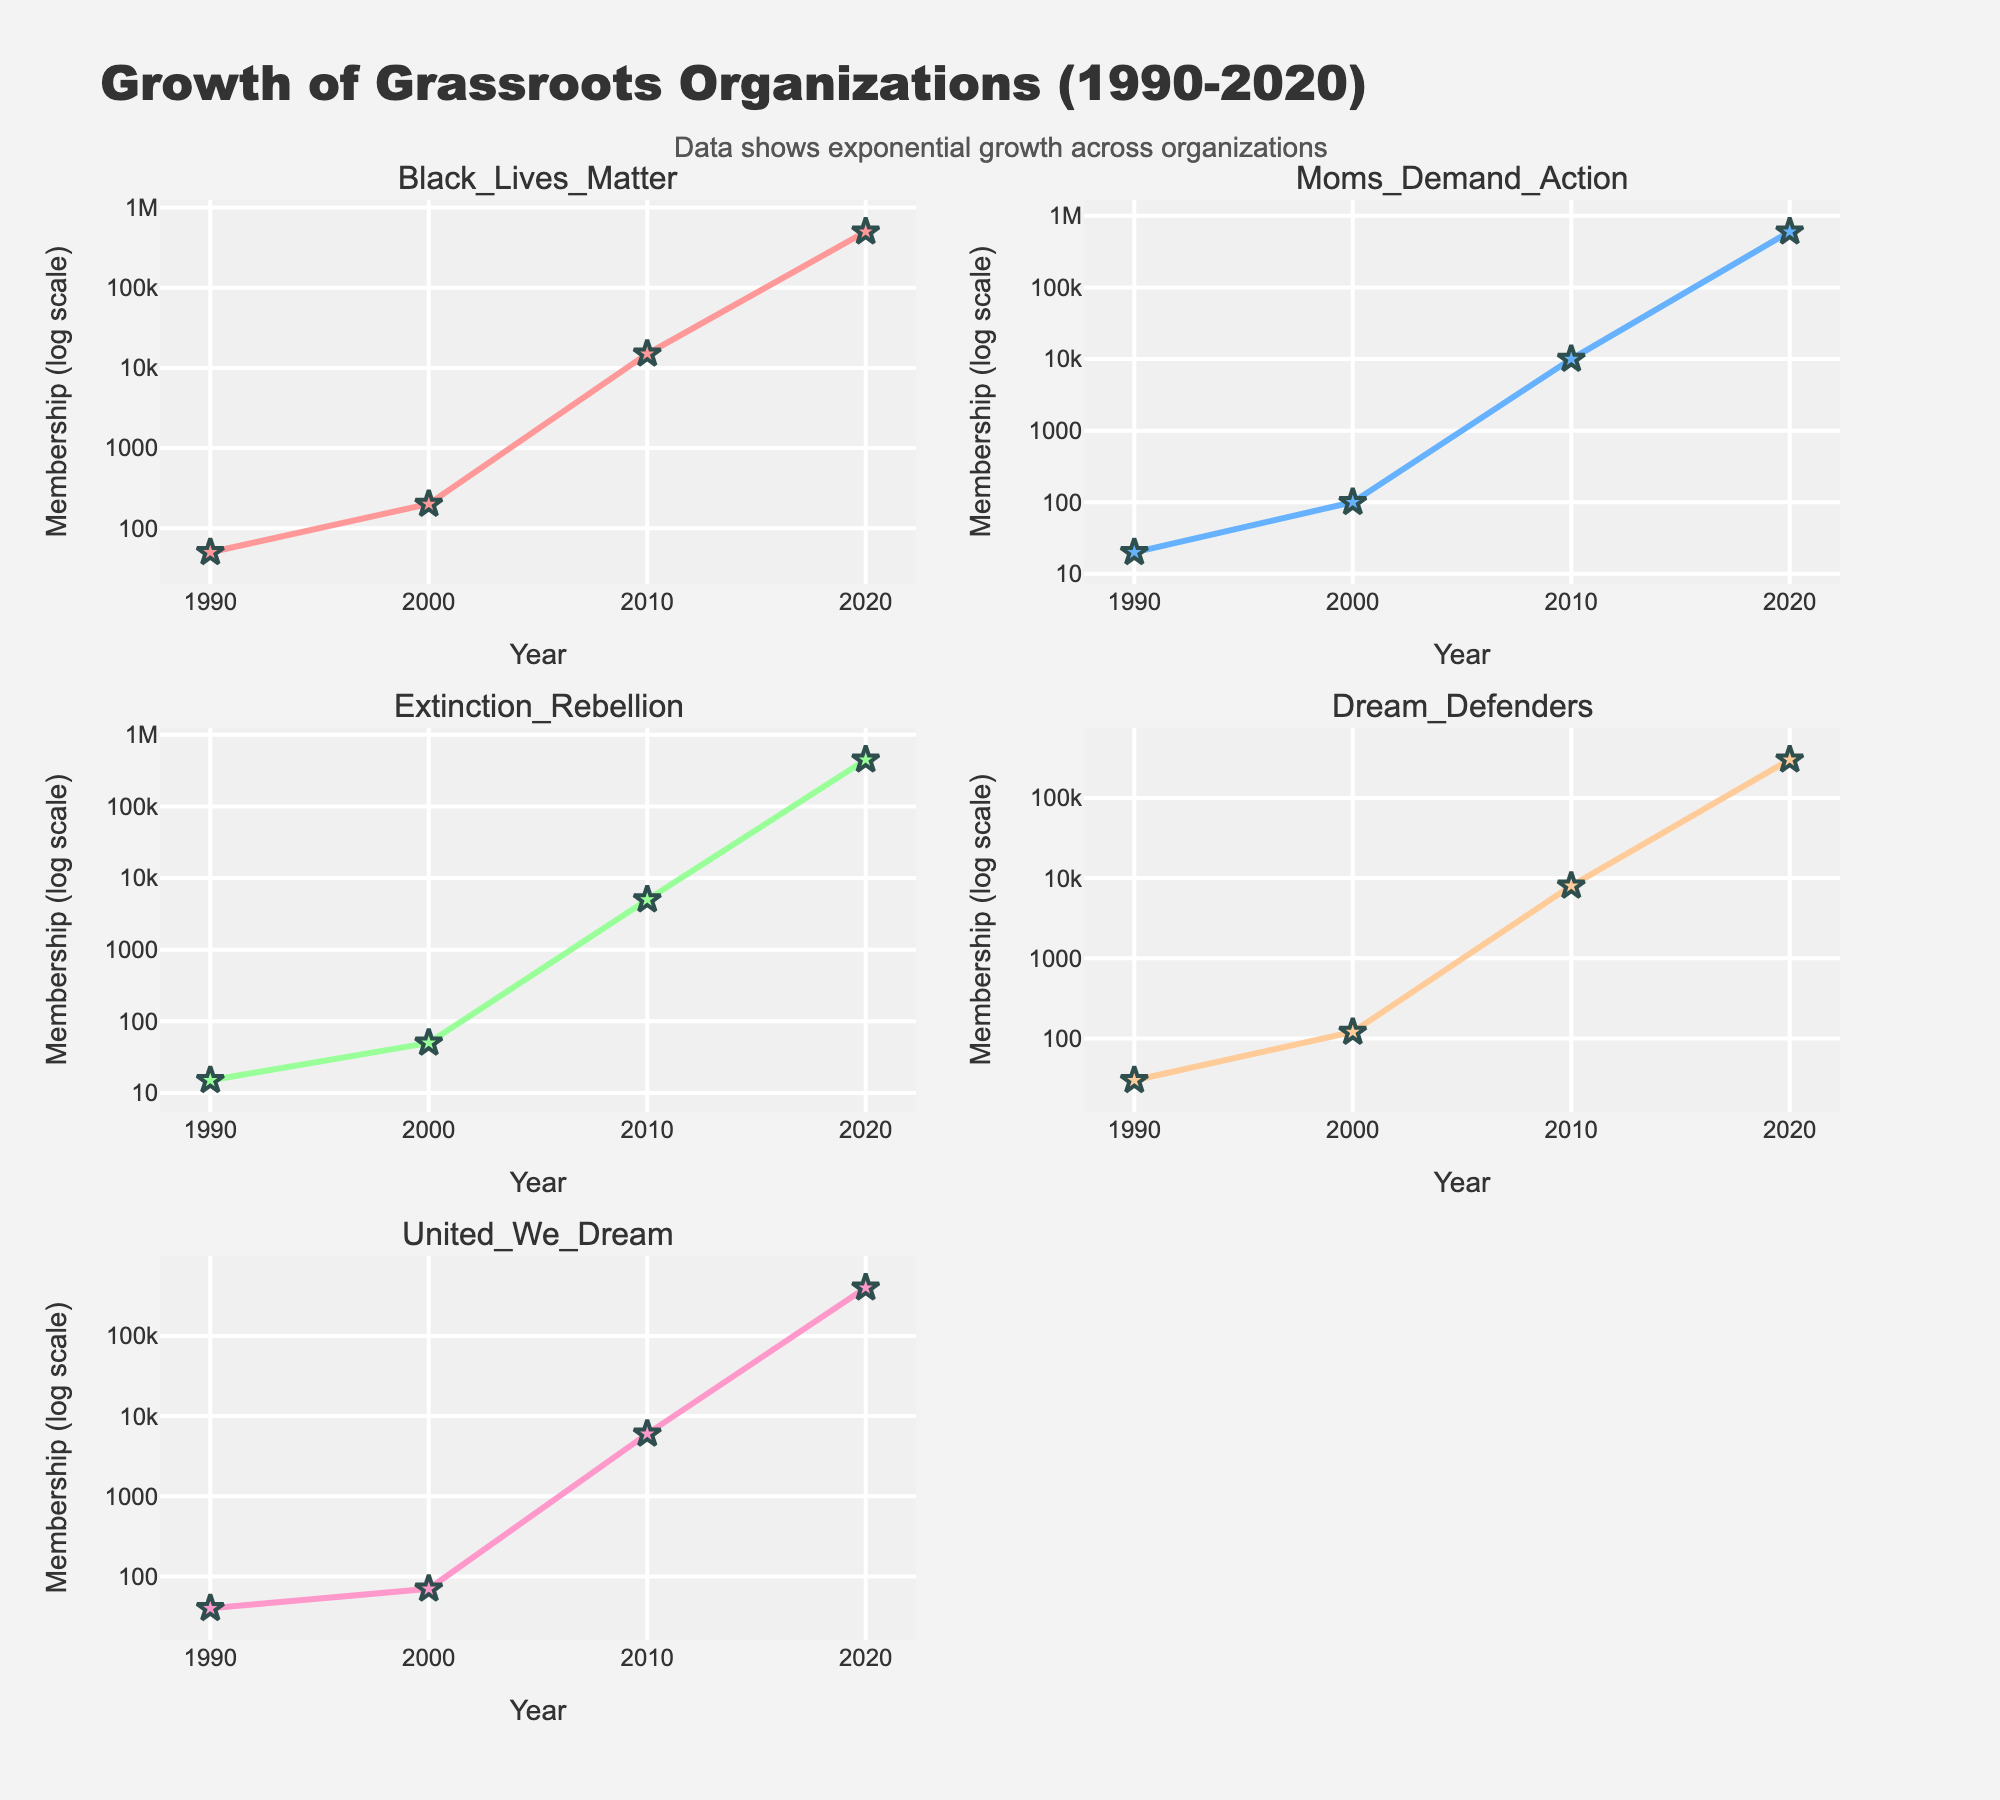What is the overall trend in the membership size of the "Black Lives Matter" organization from 1990 to 2020? To identify the trend, look at the plot for "Black Lives Matter". The plot shows an increasing trend, particularly noticeable between 2000 to 2020, where the membership size increases exponentially.
Answer: Significant growth Which organization had the highest membership size in 2020? To find this, compare the 2020 data points across all subplots. "Moms Demand Action" has the highest membership size in 2020, with 600,000 members.
Answer: Moms Demand Action Which two organizations had the least membership size in 1990 and how do they compare? By reviewing the 1990 membership data points in each subplot, "Extinction Rebellion" and "Moms Demand Action" had the least memberships, with 15 and 20 respectively. Comparing these, "Extinction Rebellion" had fewer members.
Answer: Extinction Rebellion and Moms Demand Action; Extinction Rebellion had fewer members What is the difference in membership size between "Black Lives Matter" and "Dream Defenders" in the year 2010? Check the membership size for both organizations in 2010. "Black Lives Matter" had 15,000 members, and "Dream Defenders" had 8,000 members. The difference is 15,000 - 8,000 = 7,000 members.
Answer: 7,000 Which organization showed the most rapid growth between 2010 and 2020, and how can you tell? To determine the most rapid growth, compare the slopes of the lines from 2010 to 2020 on each subplot. "Moms Demand Action" displays the steepest slope, indicating the most rapid growth from 10,000 to 600,000 members.
Answer: Moms Demand Action, steepest slope How many organizations had more than 100,000 members in 2020? Count the organizations with membership sizes above 100,000 in the 2020 data points across all subplots. All five organizations have more than 100,000 members in 2020.
Answer: Five What can you infer about the general pattern of membership growth for these grassroots organizations over the last three decades? Review the general pattern across all subplots noting the consistent exponential increase across organizations, suggesting widespread growth and increasing influence of grassroots movements over time.
Answer: Exponential growth Considering logarithmic scale, why do the differences between membership sizes in early years seem smaller than the later years despite large numerical changes? In a log scale, equal distances represent multiplicative changes rather than additive ones. Hence, the same numerical differences appear smaller earlier and larger later because they reflect proportionally equal growth.
Answer: Logarithmically equal growth 